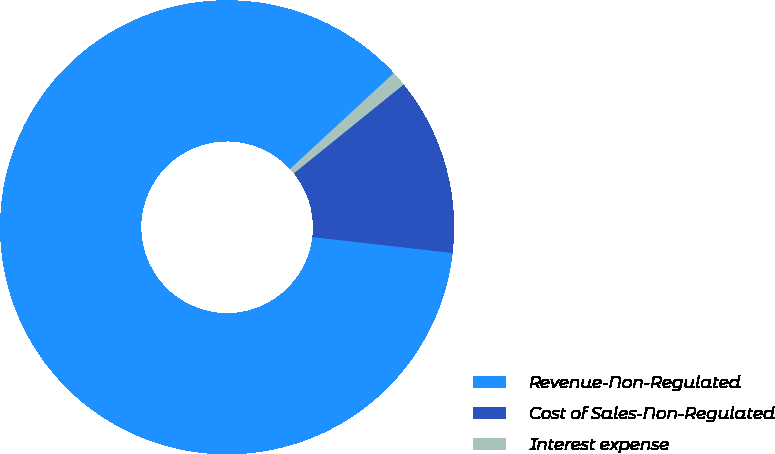<chart> <loc_0><loc_0><loc_500><loc_500><pie_chart><fcel>Revenue-Non-Regulated<fcel>Cost of Sales-Non-Regulated<fcel>Interest expense<nl><fcel>86.32%<fcel>12.63%<fcel>1.05%<nl></chart> 